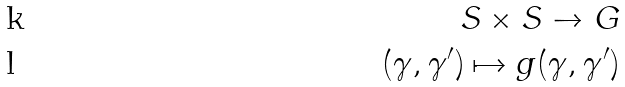Convert formula to latex. <formula><loc_0><loc_0><loc_500><loc_500>S \times S \to G \\ ( \gamma , \gamma ^ { \prime } ) \mapsto g ( \gamma , \gamma ^ { \prime } )</formula> 